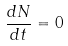Convert formula to latex. <formula><loc_0><loc_0><loc_500><loc_500>\frac { d N } { d t } = 0</formula> 